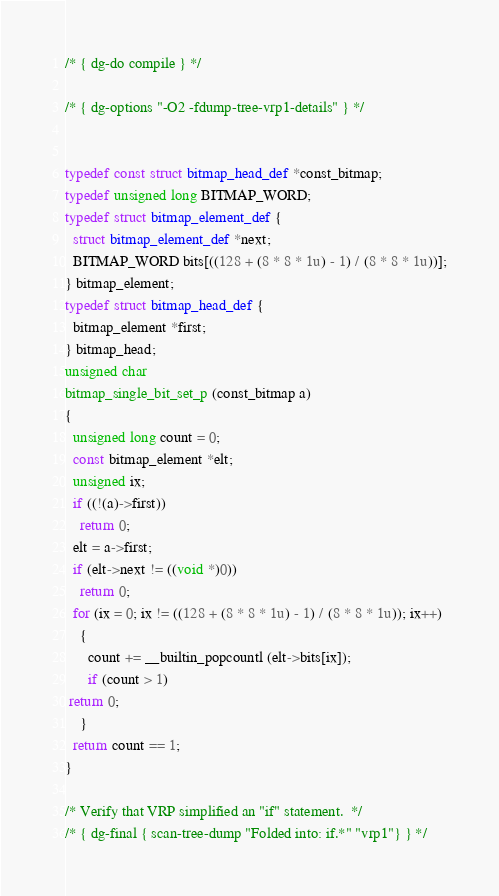<code> <loc_0><loc_0><loc_500><loc_500><_C_>/* { dg-do compile } */

/* { dg-options "-O2 -fdump-tree-vrp1-details" } */


typedef const struct bitmap_head_def *const_bitmap;
typedef unsigned long BITMAP_WORD;
typedef struct bitmap_element_def {
  struct bitmap_element_def *next;
  BITMAP_WORD bits[((128 + (8 * 8 * 1u) - 1) / (8 * 8 * 1u))];
} bitmap_element;
typedef struct bitmap_head_def {
  bitmap_element *first;
} bitmap_head;
unsigned char
bitmap_single_bit_set_p (const_bitmap a)
{
  unsigned long count = 0;
  const bitmap_element *elt;
  unsigned ix;
  if ((!(a)->first))
    return 0;
  elt = a->first;
  if (elt->next != ((void *)0))
    return 0;
  for (ix = 0; ix != ((128 + (8 * 8 * 1u) - 1) / (8 * 8 * 1u)); ix++)
    {
      count += __builtin_popcountl (elt->bits[ix]);
      if (count > 1)
 return 0;
    }
  return count == 1;
}

/* Verify that VRP simplified an "if" statement.  */
/* { dg-final { scan-tree-dump "Folded into: if.*" "vrp1"} } */


</code> 